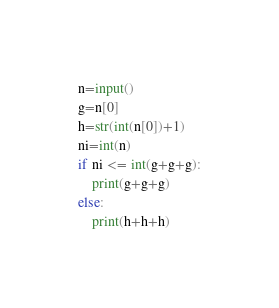Convert code to text. <code><loc_0><loc_0><loc_500><loc_500><_Python_>n=input()
g=n[0]
h=str(int(n[0])+1)
ni=int(n)
if ni <= int(g+g+g):
    print(g+g+g)
else:
    print(h+h+h)</code> 